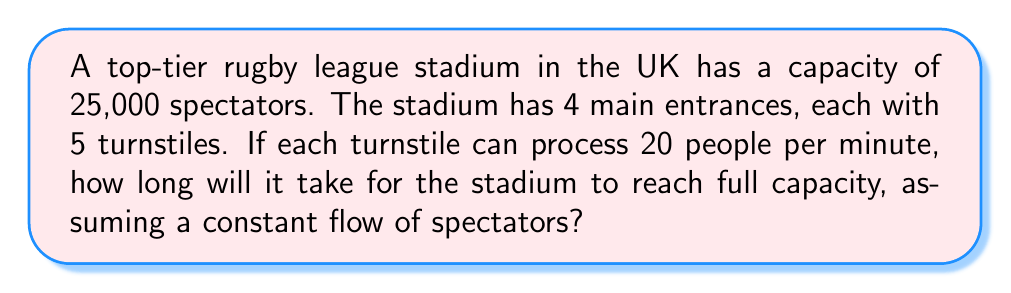Show me your answer to this math problem. Let's break this down step-by-step:

1. Calculate the total number of turnstiles:
   Number of entrances × Turnstiles per entrance = 4 × 5 = 20 turnstiles

2. Calculate the total processing capacity per minute:
   Total turnstiles × People processed per turnstile per minute
   $$ 20 \times 20 = 400 \text{ people/minute} $$

3. Calculate the time needed to process all spectators:
   $$ \text{Time} = \frac{\text{Total spectators}}{\text{Processing capacity per minute}} $$
   $$ \text{Time} = \frac{25,000}{400} = 62.5 \text{ minutes} $$

4. Convert the result to hours and minutes:
   62.5 minutes = 1 hour and 2.5 minutes ≈ 1 hour and 3 minutes

Therefore, it will take approximately 1 hour and 3 minutes for the stadium to reach full capacity under these conditions.
Answer: 1 hour and 3 minutes 